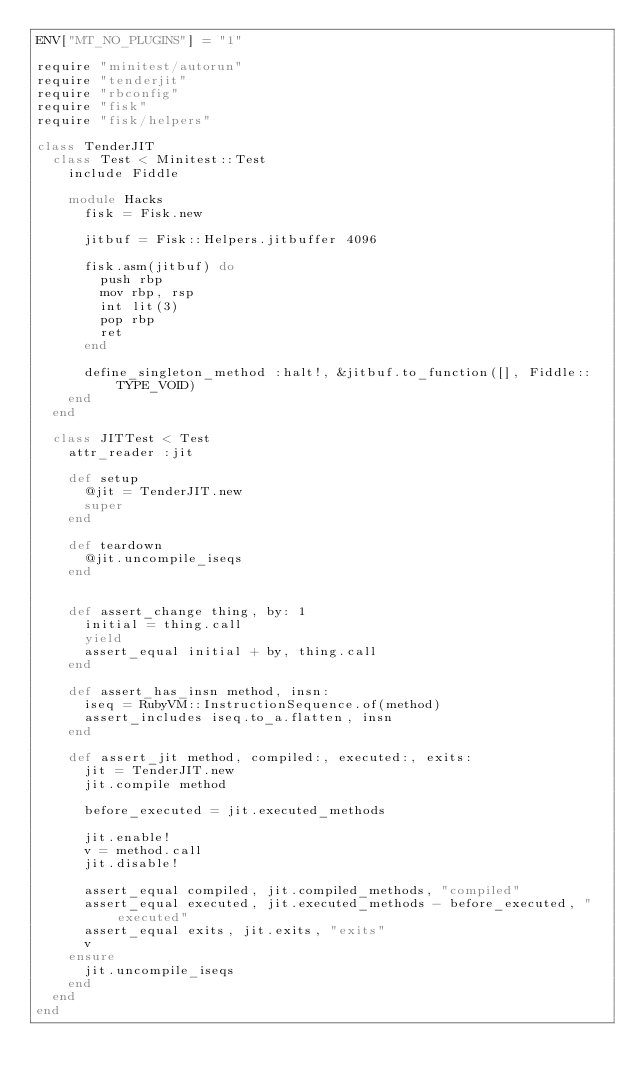<code> <loc_0><loc_0><loc_500><loc_500><_Ruby_>ENV["MT_NO_PLUGINS"] = "1"

require "minitest/autorun"
require "tenderjit"
require "rbconfig"
require "fisk"
require "fisk/helpers"

class TenderJIT
  class Test < Minitest::Test
    include Fiddle

    module Hacks
      fisk = Fisk.new

      jitbuf = Fisk::Helpers.jitbuffer 4096

      fisk.asm(jitbuf) do
        push rbp
        mov rbp, rsp
        int lit(3)
        pop rbp
        ret
      end

      define_singleton_method :halt!, &jitbuf.to_function([], Fiddle::TYPE_VOID)
    end
  end

  class JITTest < Test
    attr_reader :jit

    def setup
      @jit = TenderJIT.new
      super
    end

    def teardown
      @jit.uncompile_iseqs
    end


    def assert_change thing, by: 1
      initial = thing.call
      yield
      assert_equal initial + by, thing.call
    end

    def assert_has_insn method, insn:
      iseq = RubyVM::InstructionSequence.of(method)
      assert_includes iseq.to_a.flatten, insn
    end

    def assert_jit method, compiled:, executed:, exits:
      jit = TenderJIT.new
      jit.compile method

      before_executed = jit.executed_methods

      jit.enable!
      v = method.call
      jit.disable!

      assert_equal compiled, jit.compiled_methods, "compiled"
      assert_equal executed, jit.executed_methods - before_executed, "executed"
      assert_equal exits, jit.exits, "exits"
      v
    ensure
      jit.uncompile_iseqs
    end
  end
end
</code> 